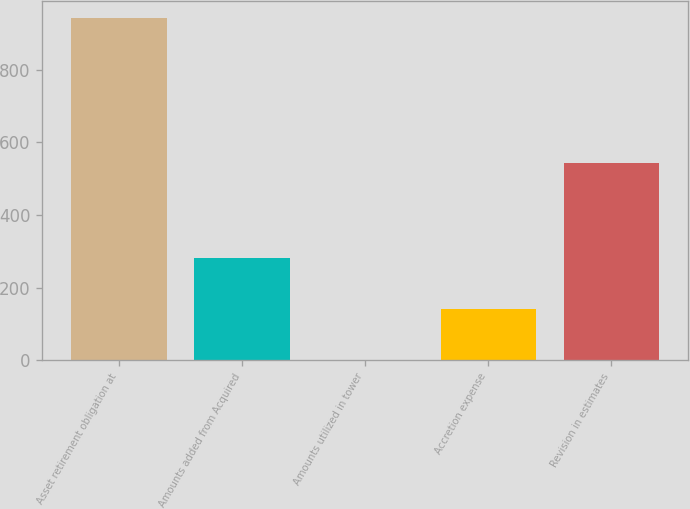Convert chart. <chart><loc_0><loc_0><loc_500><loc_500><bar_chart><fcel>Asset retirement obligation at<fcel>Amounts added from Acquired<fcel>Amounts utilized in tower<fcel>Accretion expense<fcel>Revision in estimates<nl><fcel>942<fcel>281.6<fcel>1<fcel>141.3<fcel>544<nl></chart> 